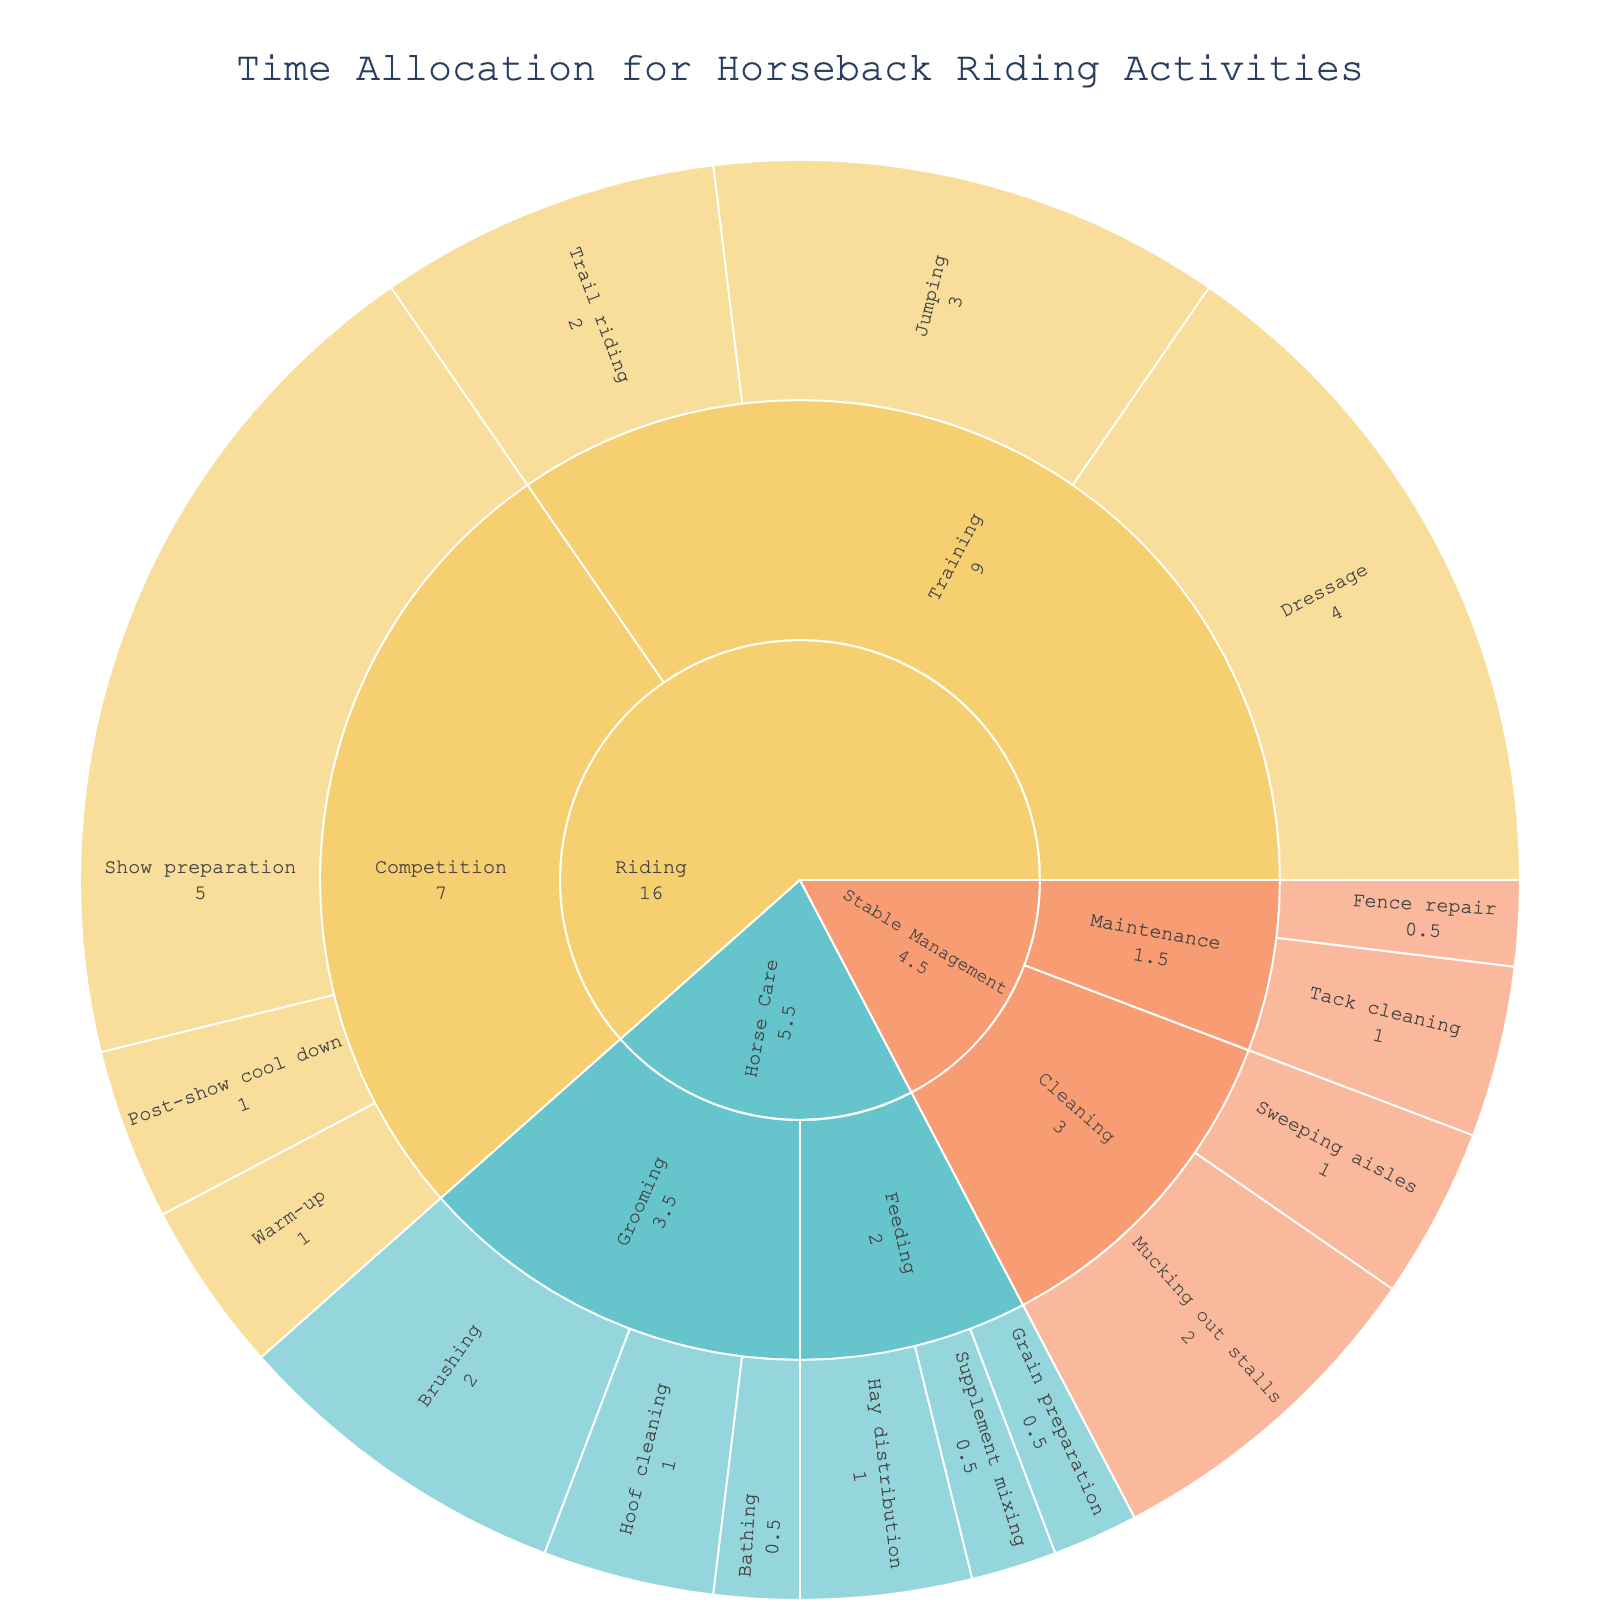What's the total time spent on all Riding activities? To find the total time spent on all Riding activities, add the times for Training (Dressage: 4, Jumping: 3, Trail riding: 2) and Competition (Show preparation: 5, Warm-up: 1, Post-show cool down: 1). The total time is 4 + 3 + 2 + 5 + 1 + 1 = 16 hours.
Answer: 16 hours Which subcategory under Horse Care takes more time, Grooming or Feeding? To determine which subcategory under Horse Care takes more time, add the times for Grooming activities (Brushing: 2, Hoof cleaning: 1, Bathing: 0.5) and Feeding activities (Hay distribution: 1, Grain preparation: 0.5, Supplement mixing: 0.5). Grooming totals 2 + 1 + 0.5 = 3.5 hours, while Feeding totals 1 + 0.5 + 0.5 = 2 hours. Therefore, Grooming takes more time.
Answer: Grooming What's the total time spent on Stable Management activities? To find the total time spent on Stable Management activities, add the times for Cleaning (Mucking out stalls: 2, Sweeping aisles: 1) and Maintenance (Tack cleaning: 1, Fence repair: 0.5). The total time is 2 + 1 + 1 + 0.5 = 4.5 hours.
Answer: 4.5 hours How much time is spent on Tack cleaning compared to Brushing? Tack cleaning takes 1 hour, and Brushing takes 2 hours. Thus, Brushing takes more time.
Answer: Brushing takes more time What's the most time-consuming activity in the Competition subcategory? The Competition subcategory includes Show preparation (5), Warm-up (1), and Post-show cool down (1). Show preparation, with 5 hours, is the most time-consuming activity.
Answer: Show preparation Which category has the highest total time allocation? To determine which category has the highest time allocation, sum up the times for Riding, Horse Care, and Stable Management. Riding (4+3+2+5+1+1 = 16), Horse Care (2+1+0.5+1+0.5+0.5 = 5.5), Stable Management (2+1+1+0.5 = 4.5). Riding has the highest total time allocation with 16 hours.
Answer: Riding 